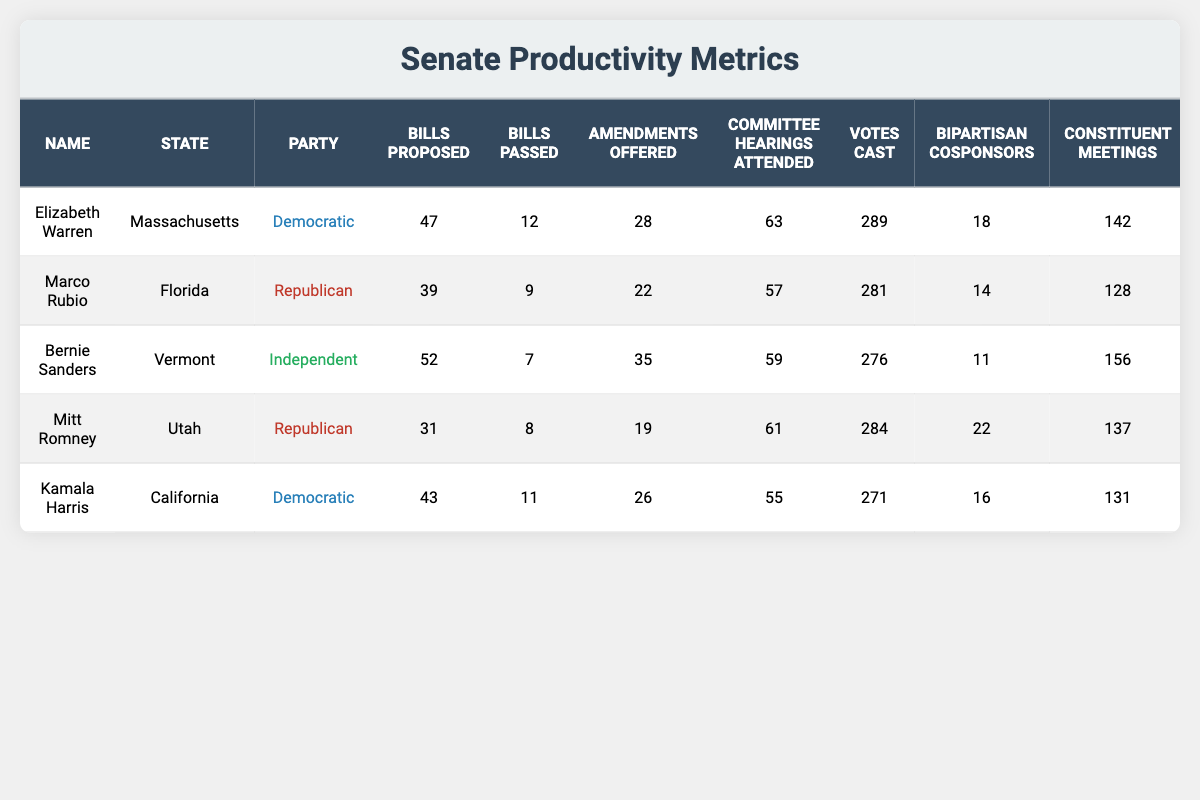What's the total number of bills proposed by all senators? To find the total number of bills proposed, we sum the bills proposed by each senator: 47 + 39 + 52 + 31 + 43 = 212.
Answer: 212 Which senator has attended the most committee hearings? By comparing the number of committee hearings attended, we see that Elizabeth Warren attended 63, which is higher than all other senators.
Answer: Elizabeth Warren What is the average number of bills passed by the senators listed? To calculate the average, first sum the total bills passed: 12 + 9 + 7 + 8 + 11 = 47. Then divide by 5 (the number of senators): 47/5 = 9.4.
Answer: 9.4 Has Kamala Harris proposed more bills than Marco Rubio? Yes, Kamala Harris proposed 43 bills while Marco Rubio proposed 39 bills, so she has proposed more.
Answer: Yes Which party has the highest average number of bills passed among its senators? First, we calculate total bills passed for each party: Democrats: (12 + 11) = 23 from 2 senators, average 23/2 = 11.5; Republicans: (9 + 8) = 17 from 2 senators, average 17/2 = 8.5; Independents: (7) from 1 senator, average 7/1 = 7. The Democrats have the highest average at 11.5.
Answer: Democratic What is the difference between the highest and lowest number of votes cast? The highest votes cast is by Elizabeth Warren (289) and the lowest is by Bernie Sanders (276). The difference is 289 - 276 = 13.
Answer: 13 Do all senators have at least 10 bills passed? No, Bernie Sanders only has 7 bills passed, which is less than 10.
Answer: No Which senator has the most bipartisan cosponsors? Mitt Romney has the most bipartisan cosponsors with a total of 22, higher than any other senator listed.
Answer: Mitt Romney How many more amendments were offered by Elizabeth Warren than by Kamala Harris? Elizabeth Warren offered 28 amendments and Kamala Harris offered 26. The difference is 28 - 26 = 2.
Answer: 2 What percentage of bills proposed by Bernie Sanders were passed? Bernie Sanders proposed 52 bills and passed 7. The percentage is (7/52) * 100 = 13.46%.
Answer: 13.46% Which senator has the least number of constituent meetings? Marco Rubio has the least number of constituent meetings at 128, compared to all other senators.
Answer: Marco Rubio 